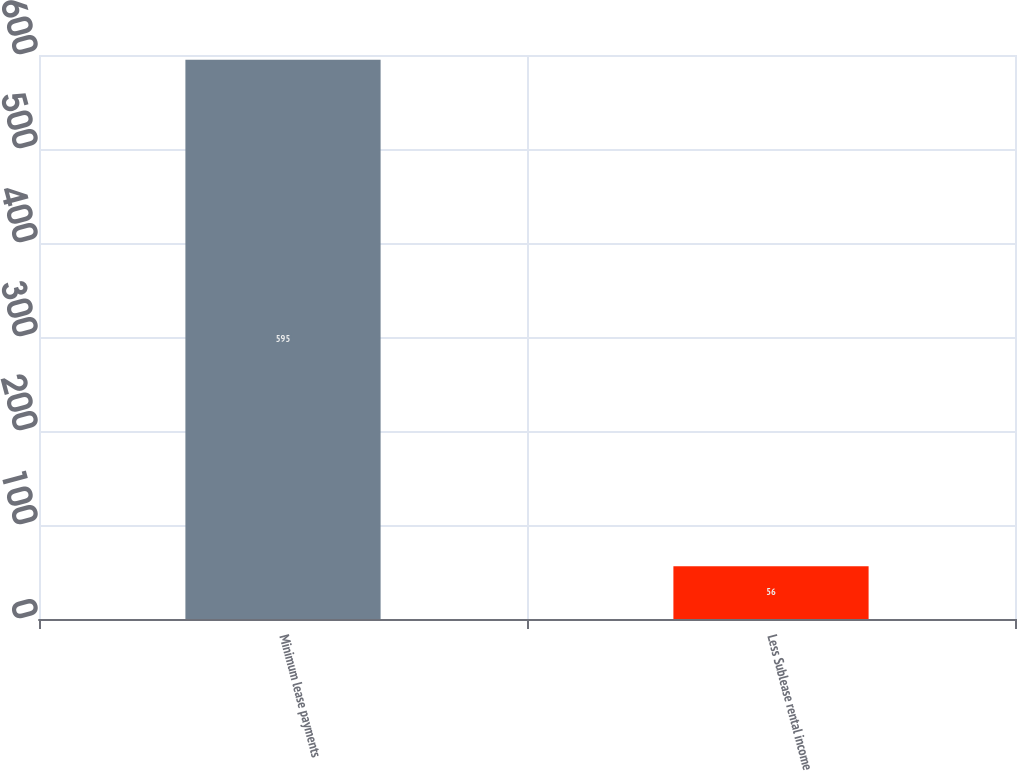Convert chart. <chart><loc_0><loc_0><loc_500><loc_500><bar_chart><fcel>Minimum lease payments<fcel>Less Sublease rental income<nl><fcel>595<fcel>56<nl></chart> 